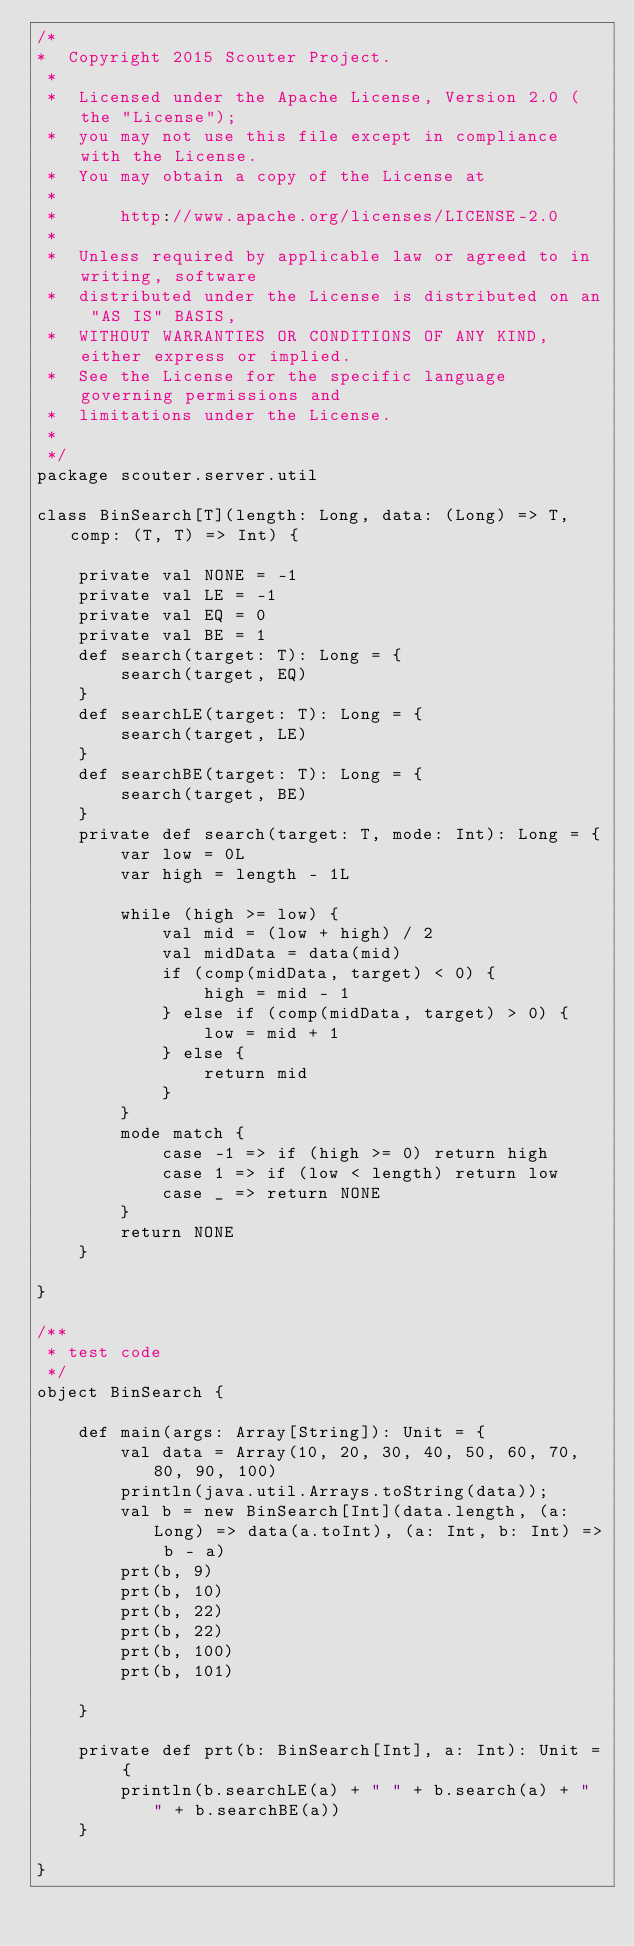Convert code to text. <code><loc_0><loc_0><loc_500><loc_500><_Scala_>/*
*  Copyright 2015 Scouter Project.
 *
 *  Licensed under the Apache License, Version 2.0 (the "License"); 
 *  you may not use this file except in compliance with the License.
 *  You may obtain a copy of the License at
 *
 *      http://www.apache.org/licenses/LICENSE-2.0
 *
 *  Unless required by applicable law or agreed to in writing, software
 *  distributed under the License is distributed on an "AS IS" BASIS,
 *  WITHOUT WARRANTIES OR CONDITIONS OF ANY KIND, either express or implied.
 *  See the License for the specific language governing permissions and
 *  limitations under the License. 
 *
 */
package scouter.server.util

class BinSearch[T](length: Long, data: (Long) => T, comp: (T, T) => Int) {

    private val NONE = -1
    private val LE = -1
    private val EQ = 0
    private val BE = 1
    def search(target: T): Long = {
        search(target, EQ)
    }
    def searchLE(target: T): Long = {
        search(target, LE)
    }
    def searchBE(target: T): Long = {
        search(target, BE)
    }
    private def search(target: T, mode: Int): Long = {
        var low = 0L
        var high = length - 1L

        while (high >= low) {
            val mid = (low + high) / 2
            val midData = data(mid)
            if (comp(midData, target) < 0) {
                high = mid - 1
            } else if (comp(midData, target) > 0) {
                low = mid + 1
            } else {
                return mid
            }
        }
        mode match {
            case -1 => if (high >= 0) return high
            case 1 => if (low < length) return low
            case _ => return NONE
        }
        return NONE
    }

}

/**
 * test code
 */
object BinSearch {

    def main(args: Array[String]): Unit = {
        val data = Array(10, 20, 30, 40, 50, 60, 70, 80, 90, 100)
        println(java.util.Arrays.toString(data));
        val b = new BinSearch[Int](data.length, (a: Long) => data(a.toInt), (a: Int, b: Int) => b - a)
        prt(b, 9)
        prt(b, 10)
        prt(b, 22)
        prt(b, 22)
        prt(b, 100)
        prt(b, 101)

    }

    private def prt(b: BinSearch[Int], a: Int): Unit = {
        println(b.searchLE(a) + " " + b.search(a) + " " + b.searchBE(a))
    }

}</code> 